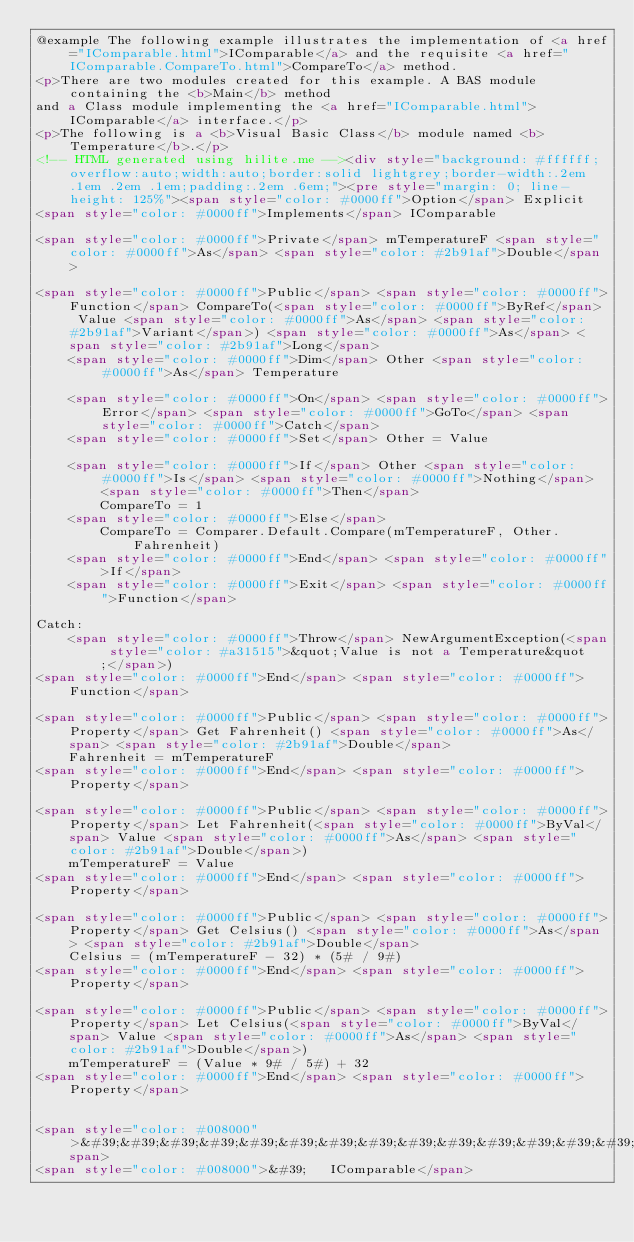<code> <loc_0><loc_0><loc_500><loc_500><_HTML_>@example The following example illustrates the implementation of <a href="IComparable.html">IComparable</a> and the requisite <a href="IComparable.CompareTo.html">CompareTo</a> method.
<p>There are two modules created for this example. A BAS module containing the <b>Main</b> method
and a Class module implementing the <a href="IComparable.html">IComparable</a> interface.</p>
<p>The following is a <b>Visual Basic Class</b> module named <b>Temperature</b>.</p>
<!-- HTML generated using hilite.me --><div style="background: #ffffff; overflow:auto;width:auto;border:solid lightgrey;border-width:.2em .1em .2em .1em;padding:.2em .6em;"><pre style="margin: 0; line-height: 125%"><span style="color: #0000ff">Option</span> Explicit
<span style="color: #0000ff">Implements</span> IComparable

<span style="color: #0000ff">Private</span> mTemperatureF <span style="color: #0000ff">As</span> <span style="color: #2b91af">Double</span>

<span style="color: #0000ff">Public</span> <span style="color: #0000ff">Function</span> CompareTo(<span style="color: #0000ff">ByRef</span> Value <span style="color: #0000ff">As</span> <span style="color: #2b91af">Variant</span>) <span style="color: #0000ff">As</span> <span style="color: #2b91af">Long</span>
    <span style="color: #0000ff">Dim</span> Other <span style="color: #0000ff">As</span> Temperature
    
    <span style="color: #0000ff">On</span> <span style="color: #0000ff">Error</span> <span style="color: #0000ff">GoTo</span> <span style="color: #0000ff">Catch</span>
    <span style="color: #0000ff">Set</span> Other = Value
    
    <span style="color: #0000ff">If</span> Other <span style="color: #0000ff">Is</span> <span style="color: #0000ff">Nothing</span> <span style="color: #0000ff">Then</span>
        CompareTo = 1
    <span style="color: #0000ff">Else</span>
        CompareTo = Comparer.Default.Compare(mTemperatureF, Other.Fahrenheit)
    <span style="color: #0000ff">End</span> <span style="color: #0000ff">If</span>
    <span style="color: #0000ff">Exit</span> <span style="color: #0000ff">Function</span>
    
Catch:
    <span style="color: #0000ff">Throw</span> NewArgumentException(<span style="color: #a31515">&quot;Value is not a Temperature&quot;</span>)
<span style="color: #0000ff">End</span> <span style="color: #0000ff">Function</span>

<span style="color: #0000ff">Public</span> <span style="color: #0000ff">Property</span> Get Fahrenheit() <span style="color: #0000ff">As</span> <span style="color: #2b91af">Double</span>
    Fahrenheit = mTemperatureF
<span style="color: #0000ff">End</span> <span style="color: #0000ff">Property</span>

<span style="color: #0000ff">Public</span> <span style="color: #0000ff">Property</span> Let Fahrenheit(<span style="color: #0000ff">ByVal</span> Value <span style="color: #0000ff">As</span> <span style="color: #2b91af">Double</span>)
    mTemperatureF = Value
<span style="color: #0000ff">End</span> <span style="color: #0000ff">Property</span>

<span style="color: #0000ff">Public</span> <span style="color: #0000ff">Property</span> Get Celsius() <span style="color: #0000ff">As</span> <span style="color: #2b91af">Double</span>
    Celsius = (mTemperatureF - 32) * (5# / 9#)
<span style="color: #0000ff">End</span> <span style="color: #0000ff">Property</span>

<span style="color: #0000ff">Public</span> <span style="color: #0000ff">Property</span> Let Celsius(<span style="color: #0000ff">ByVal</span> Value <span style="color: #0000ff">As</span> <span style="color: #2b91af">Double</span>)
    mTemperatureF = (Value * 9# / 5#) + 32
<span style="color: #0000ff">End</span> <span style="color: #0000ff">Property</span>


<span style="color: #008000">&#39;&#39;&#39;&#39;&#39;&#39;&#39;&#39;&#39;&#39;&#39;&#39;&#39;&#39;&#39;&#39;&#39;&#39;&#39;&#39;&#39;&#39;&#39;&#39;&#39;&#39;&#39;&#39;&#39;&#39;&#39;&#39;&#39;&#39;&#39;&#39;&#39;&#39;&#39;&#39;&#39;&#39;&#39;&#39;&#39;&#39;&#39;&#39;&#39;&#39;&#39;&#39;&#39;&#39;&#39;&#39;&#39;&#39;&#39;&#39;&#39;</span>
<span style="color: #008000">&#39;   IComparable</span></code> 